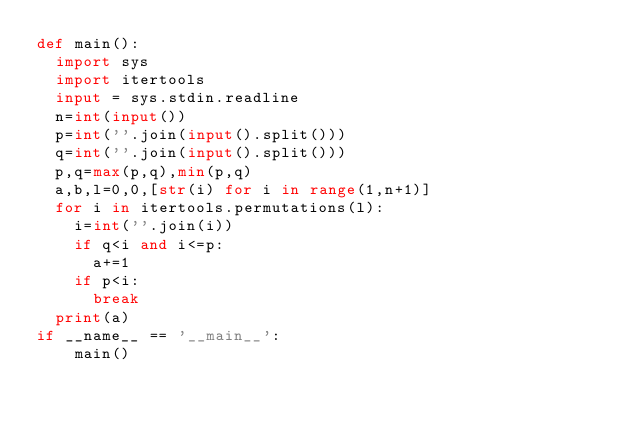Convert code to text. <code><loc_0><loc_0><loc_500><loc_500><_Python_>def main():
  import sys
  import itertools
  input = sys.stdin.readline
  n=int(input())
  p=int(''.join(input().split()))
  q=int(''.join(input().split()))
  p,q=max(p,q),min(p,q)
  a,b,l=0,0,[str(i) for i in range(1,n+1)]
  for i in itertools.permutations(l):
    i=int(''.join(i))
    if q<i and i<=p:
      a+=1
    if p<i:
      break
  print(a)  
if __name__ == '__main__':
    main()</code> 